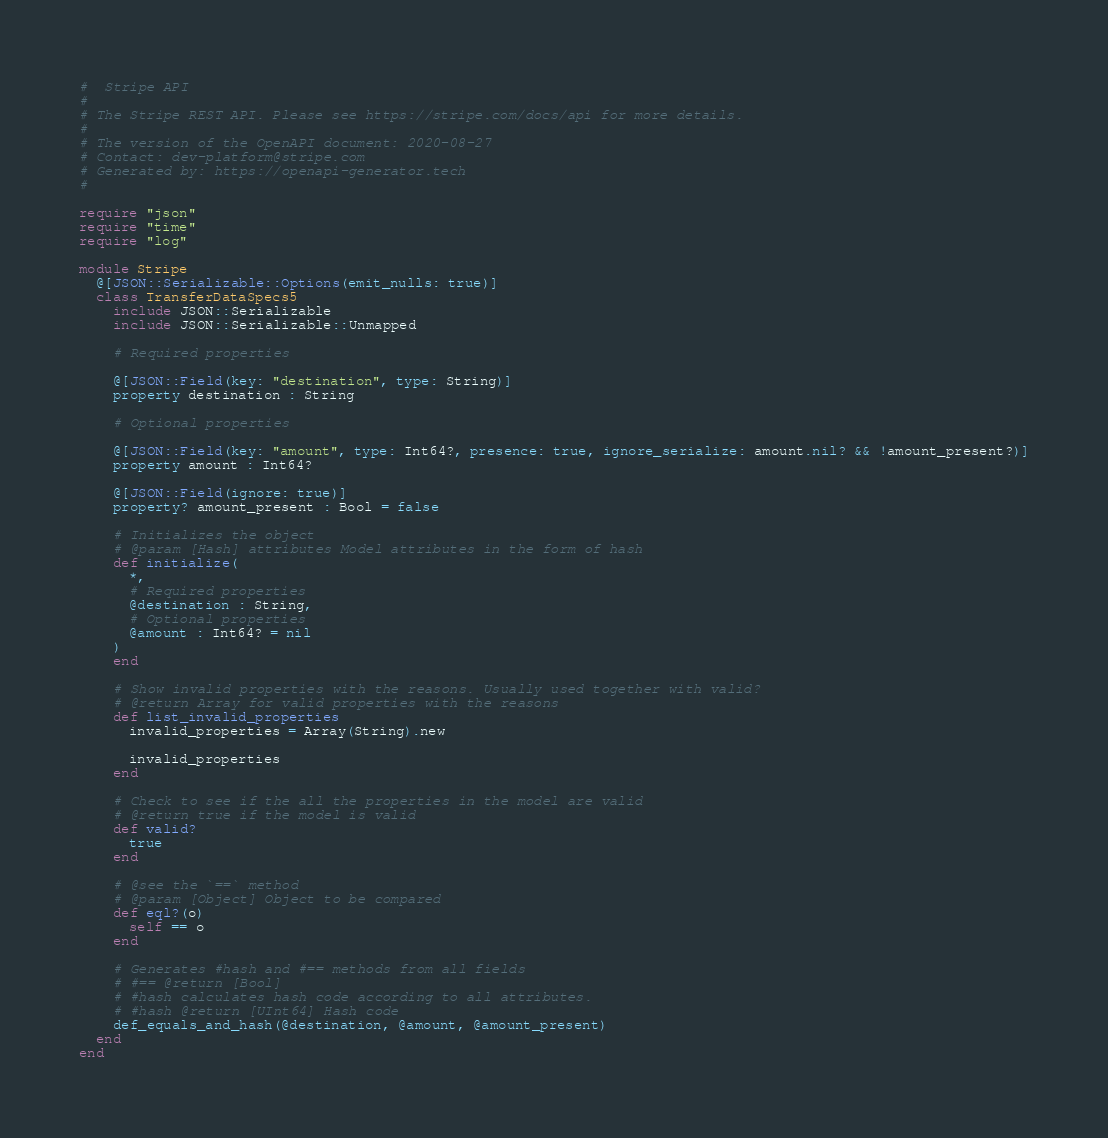Convert code to text. <code><loc_0><loc_0><loc_500><loc_500><_Crystal_>#  Stripe API
#
# The Stripe REST API. Please see https://stripe.com/docs/api for more details.
#
# The version of the OpenAPI document: 2020-08-27
# Contact: dev-platform@stripe.com
# Generated by: https://openapi-generator.tech
#

require "json"
require "time"
require "log"

module Stripe
  @[JSON::Serializable::Options(emit_nulls: true)]
  class TransferDataSpecs5
    include JSON::Serializable
    include JSON::Serializable::Unmapped

    # Required properties

    @[JSON::Field(key: "destination", type: String)]
    property destination : String

    # Optional properties

    @[JSON::Field(key: "amount", type: Int64?, presence: true, ignore_serialize: amount.nil? && !amount_present?)]
    property amount : Int64?

    @[JSON::Field(ignore: true)]
    property? amount_present : Bool = false

    # Initializes the object
    # @param [Hash] attributes Model attributes in the form of hash
    def initialize(
      *,
      # Required properties
      @destination : String,
      # Optional properties
      @amount : Int64? = nil
    )
    end

    # Show invalid properties with the reasons. Usually used together with valid?
    # @return Array for valid properties with the reasons
    def list_invalid_properties
      invalid_properties = Array(String).new

      invalid_properties
    end

    # Check to see if the all the properties in the model are valid
    # @return true if the model is valid
    def valid?
      true
    end

    # @see the `==` method
    # @param [Object] Object to be compared
    def eql?(o)
      self == o
    end

    # Generates #hash and #== methods from all fields
    # #== @return [Bool]
    # #hash calculates hash code according to all attributes.
    # #hash @return [UInt64] Hash code
    def_equals_and_hash(@destination, @amount, @amount_present)
  end
end
</code> 